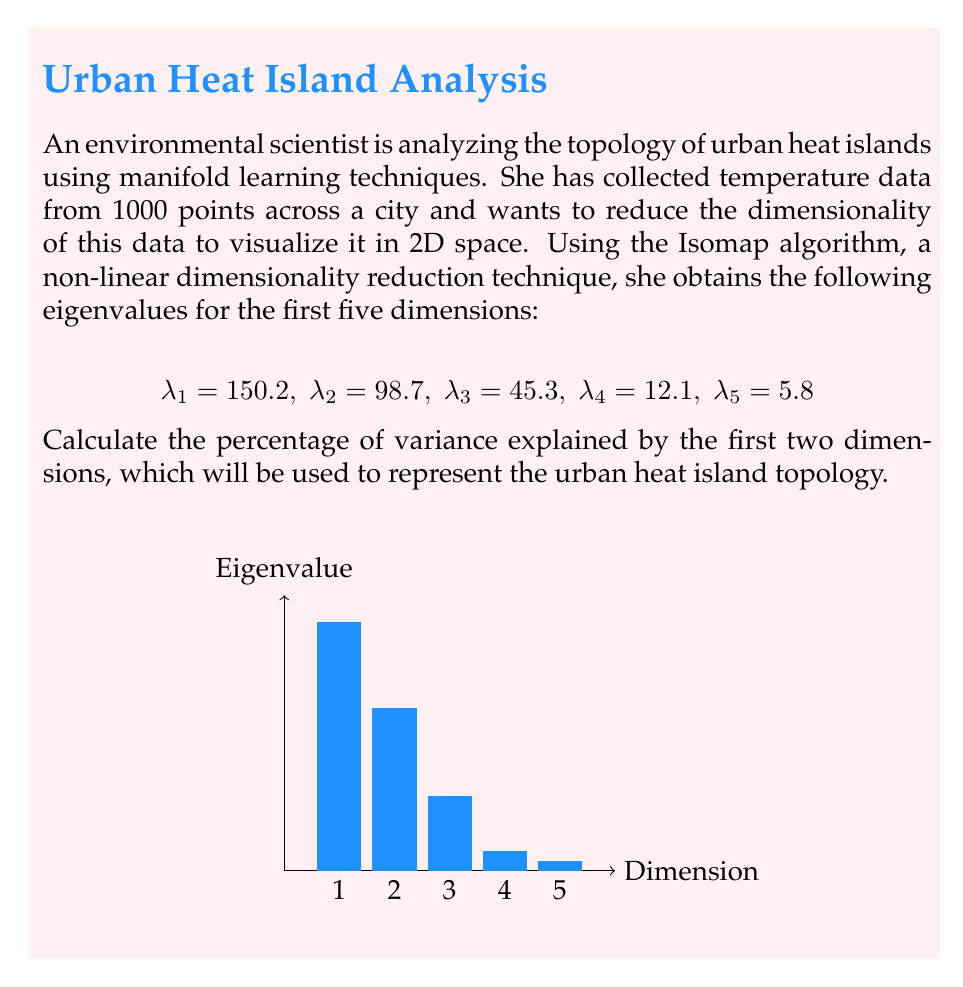Give your solution to this math problem. To solve this problem, we'll follow these steps:

1) First, we need to calculate the total variance, which is the sum of all eigenvalues:

   $$\text{Total Variance} = \sum_{i=1}^5 \lambda_i = 150.2 + 98.7 + 45.3 + 12.1 + 5.8 = 312.1$$

2) Next, we calculate the variance explained by the first two dimensions:

   $$\text{Variance of first two dimensions} = \lambda_1 + \lambda_2 = 150.2 + 98.7 = 248.9$$

3) Now, we can calculate the percentage of variance explained by the first two dimensions:

   $$\text{Percentage} = \frac{\text{Variance of first two dimensions}}{\text{Total Variance}} \times 100\%$$

   $$= \frac{248.9}{312.1} \times 100\% = 0.7974 \times 100\% = 79.74\%$$

4) Rounding to two decimal places:

   $$79.74\% \approx 79.75\%$$

This high percentage indicates that the first two dimensions capture a significant amount of the data's structure, suggesting that the 2D representation will be a good approximation of the urban heat island topology.
Answer: 79.75% 